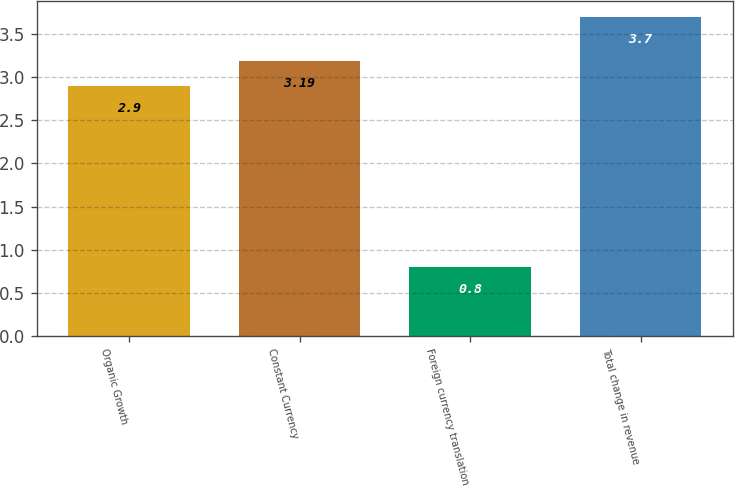Convert chart. <chart><loc_0><loc_0><loc_500><loc_500><bar_chart><fcel>Organic Growth<fcel>Constant Currency<fcel>Foreign currency translation<fcel>Total change in revenue<nl><fcel>2.9<fcel>3.19<fcel>0.8<fcel>3.7<nl></chart> 